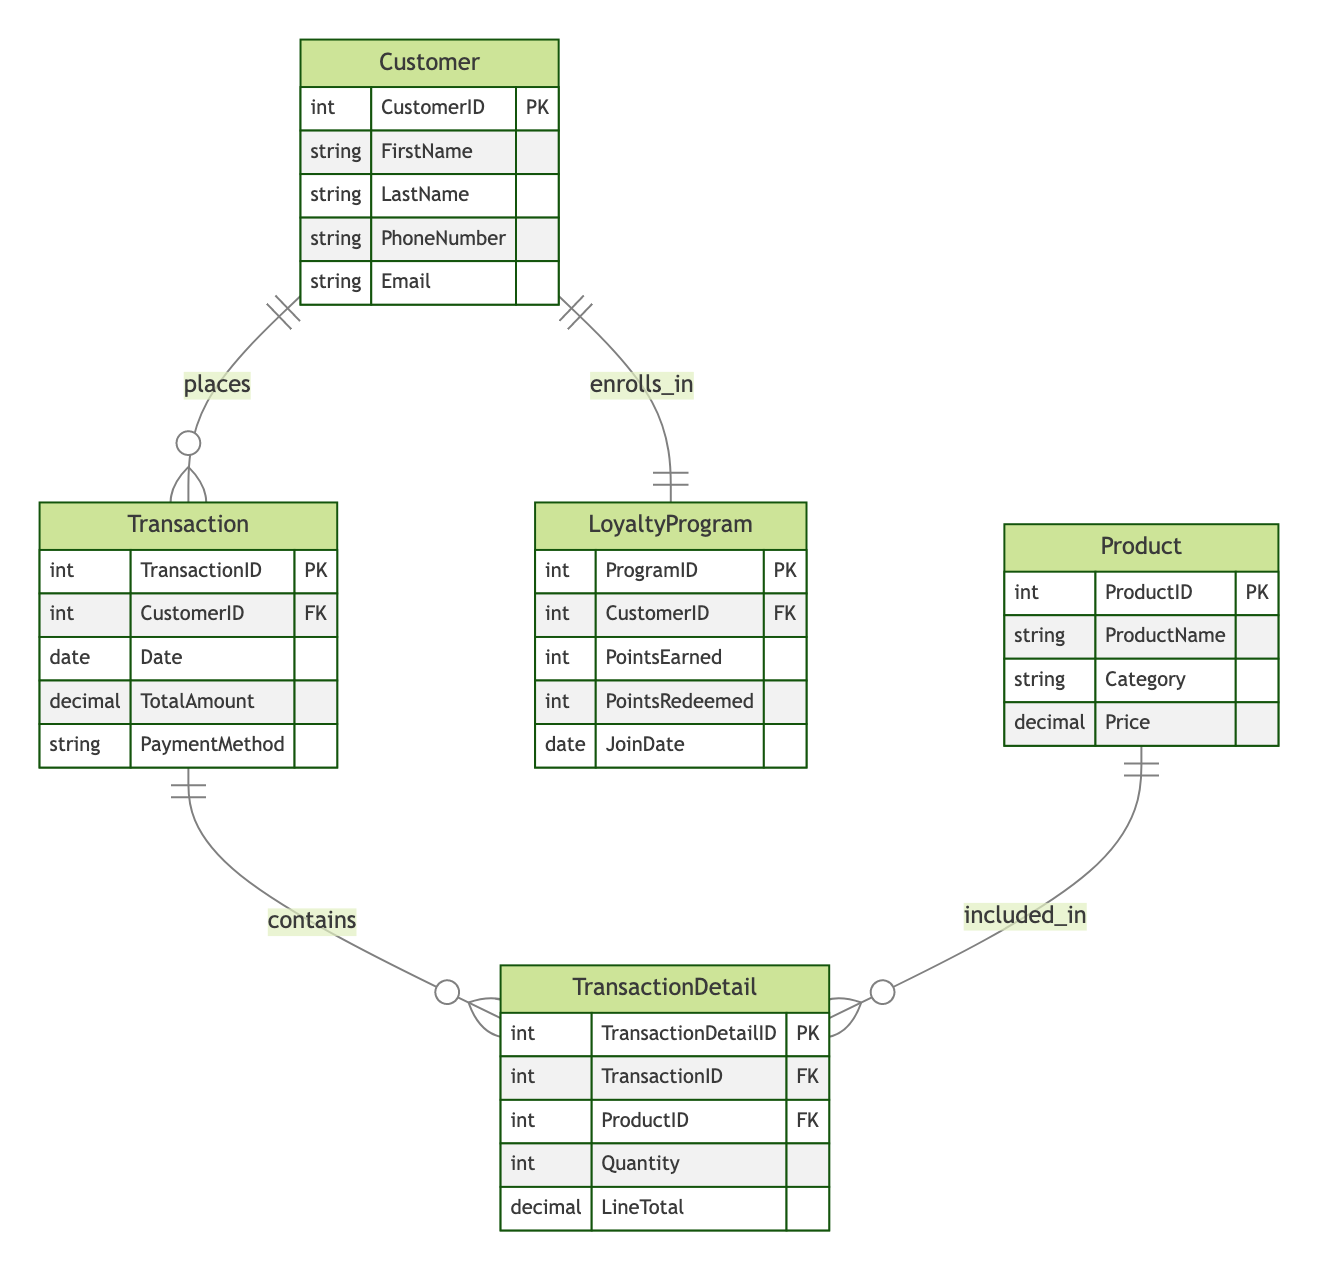What is the primary key of the Customer entity? The primary key is represented as "PK" in the diagram, and for the Customer entity, it is "CustomerID".
Answer: CustomerID How many entities are there in the diagram? The diagram lists five entities: Customer, Transaction, Product, TransactionDetail, and LoyaltyProgram. Therefore, the total count is five.
Answer: 5 What type of relationship exists between Customer and Transaction? The diagram shows a "One-to-Many" relationship between Customer and Transaction, indicating that one customer can have multiple transactions.
Answer: One-to-Many Which entity contains the attribute "PointsRedeemed"? The "PointsRedeemed" attribute is found within the LoyaltyProgram entity.
Answer: LoyaltyProgram How many foreign keys are present in the Transaction entity? The Transaction entity has one foreign key, which is "CustomerID" linking it to the Customer entity.
Answer: 1 What does the TransactionDetail entity represent in the context of a transaction? The TransactionDetail entity contains details about each product involved in a specific transaction, including the quantity and line total.
Answer: Details of products in transaction Which entity has a one-to-one relationship with the Customer entity? The LoyaltyProgram entity has a one-to-one relationship with the Customer entity, meaning each customer can only be enrolled in one loyalty program at a time.
Answer: LoyaltyProgram How is the Product entity related to the TransactionDetail entity? The diagram depicts a "One-to-Many" relationship, meaning each product can be included in multiple transaction details.
Answer: One-to-Many What is the primary key of the Transaction entity? The primary key of the Transaction entity is indicated as "TransactionID" and is noted as "PK" in the diagram.
Answer: TransactionID What is the purpose of the LoyaltyProgram entity in the diagram? The LoyaltyProgram entity tracks the loyalty points earned and redeemed by each customer, as well as their enrollment date.
Answer: Track loyalty points and enrollment 